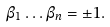Convert formula to latex. <formula><loc_0><loc_0><loc_500><loc_500>\beta _ { 1 } \dots \beta _ { n } = \pm 1 .</formula> 